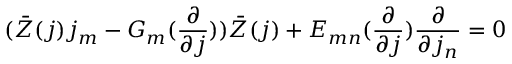<formula> <loc_0><loc_0><loc_500><loc_500>( \bar { Z } ( j ) j _ { m } - G _ { m } ( \frac { \partial } { \partial j } ) ) \bar { Z } ( j ) + E _ { m n } ( \frac { \partial } { \partial j } ) \frac { \partial } { \partial j _ { n } } = 0</formula> 